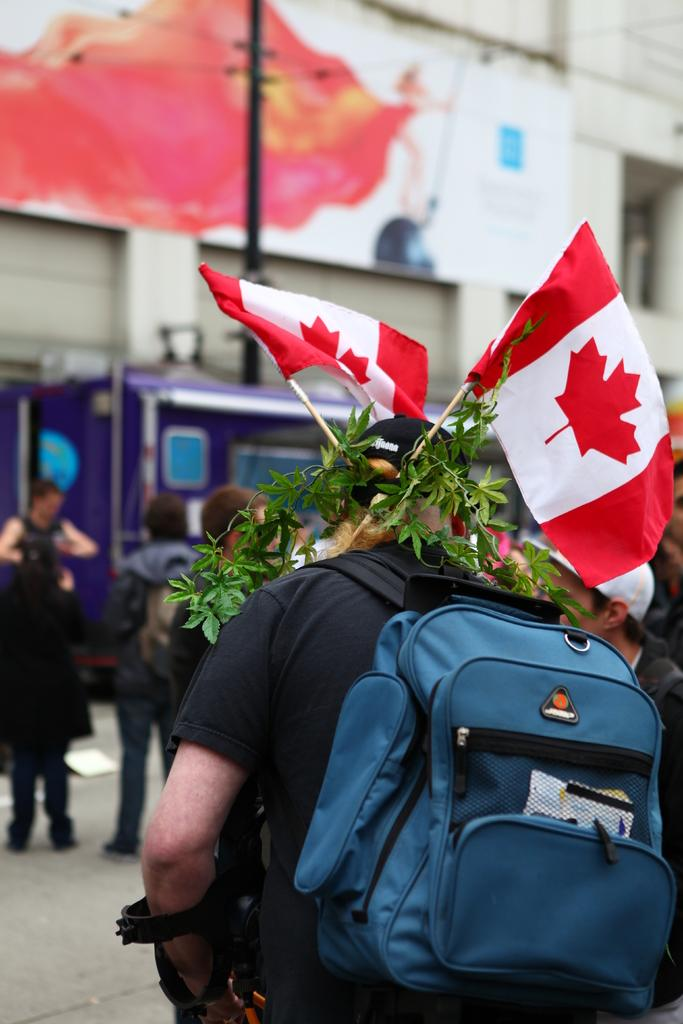Where is the image taken? The image is taken outside a road. Can you describe the person in the image? The man in the image is wearing a black t-shirt and a cap, and he is carrying a bag. What is unique about the man's appearance? The man has two flags fixed on his head. What is in front of the man? There are people and a building in front of the man. How many spiders are crawling on the man's bag in the image? There are no spiders visible in the image; the man is carrying a bag, but there is no mention of spiders. 